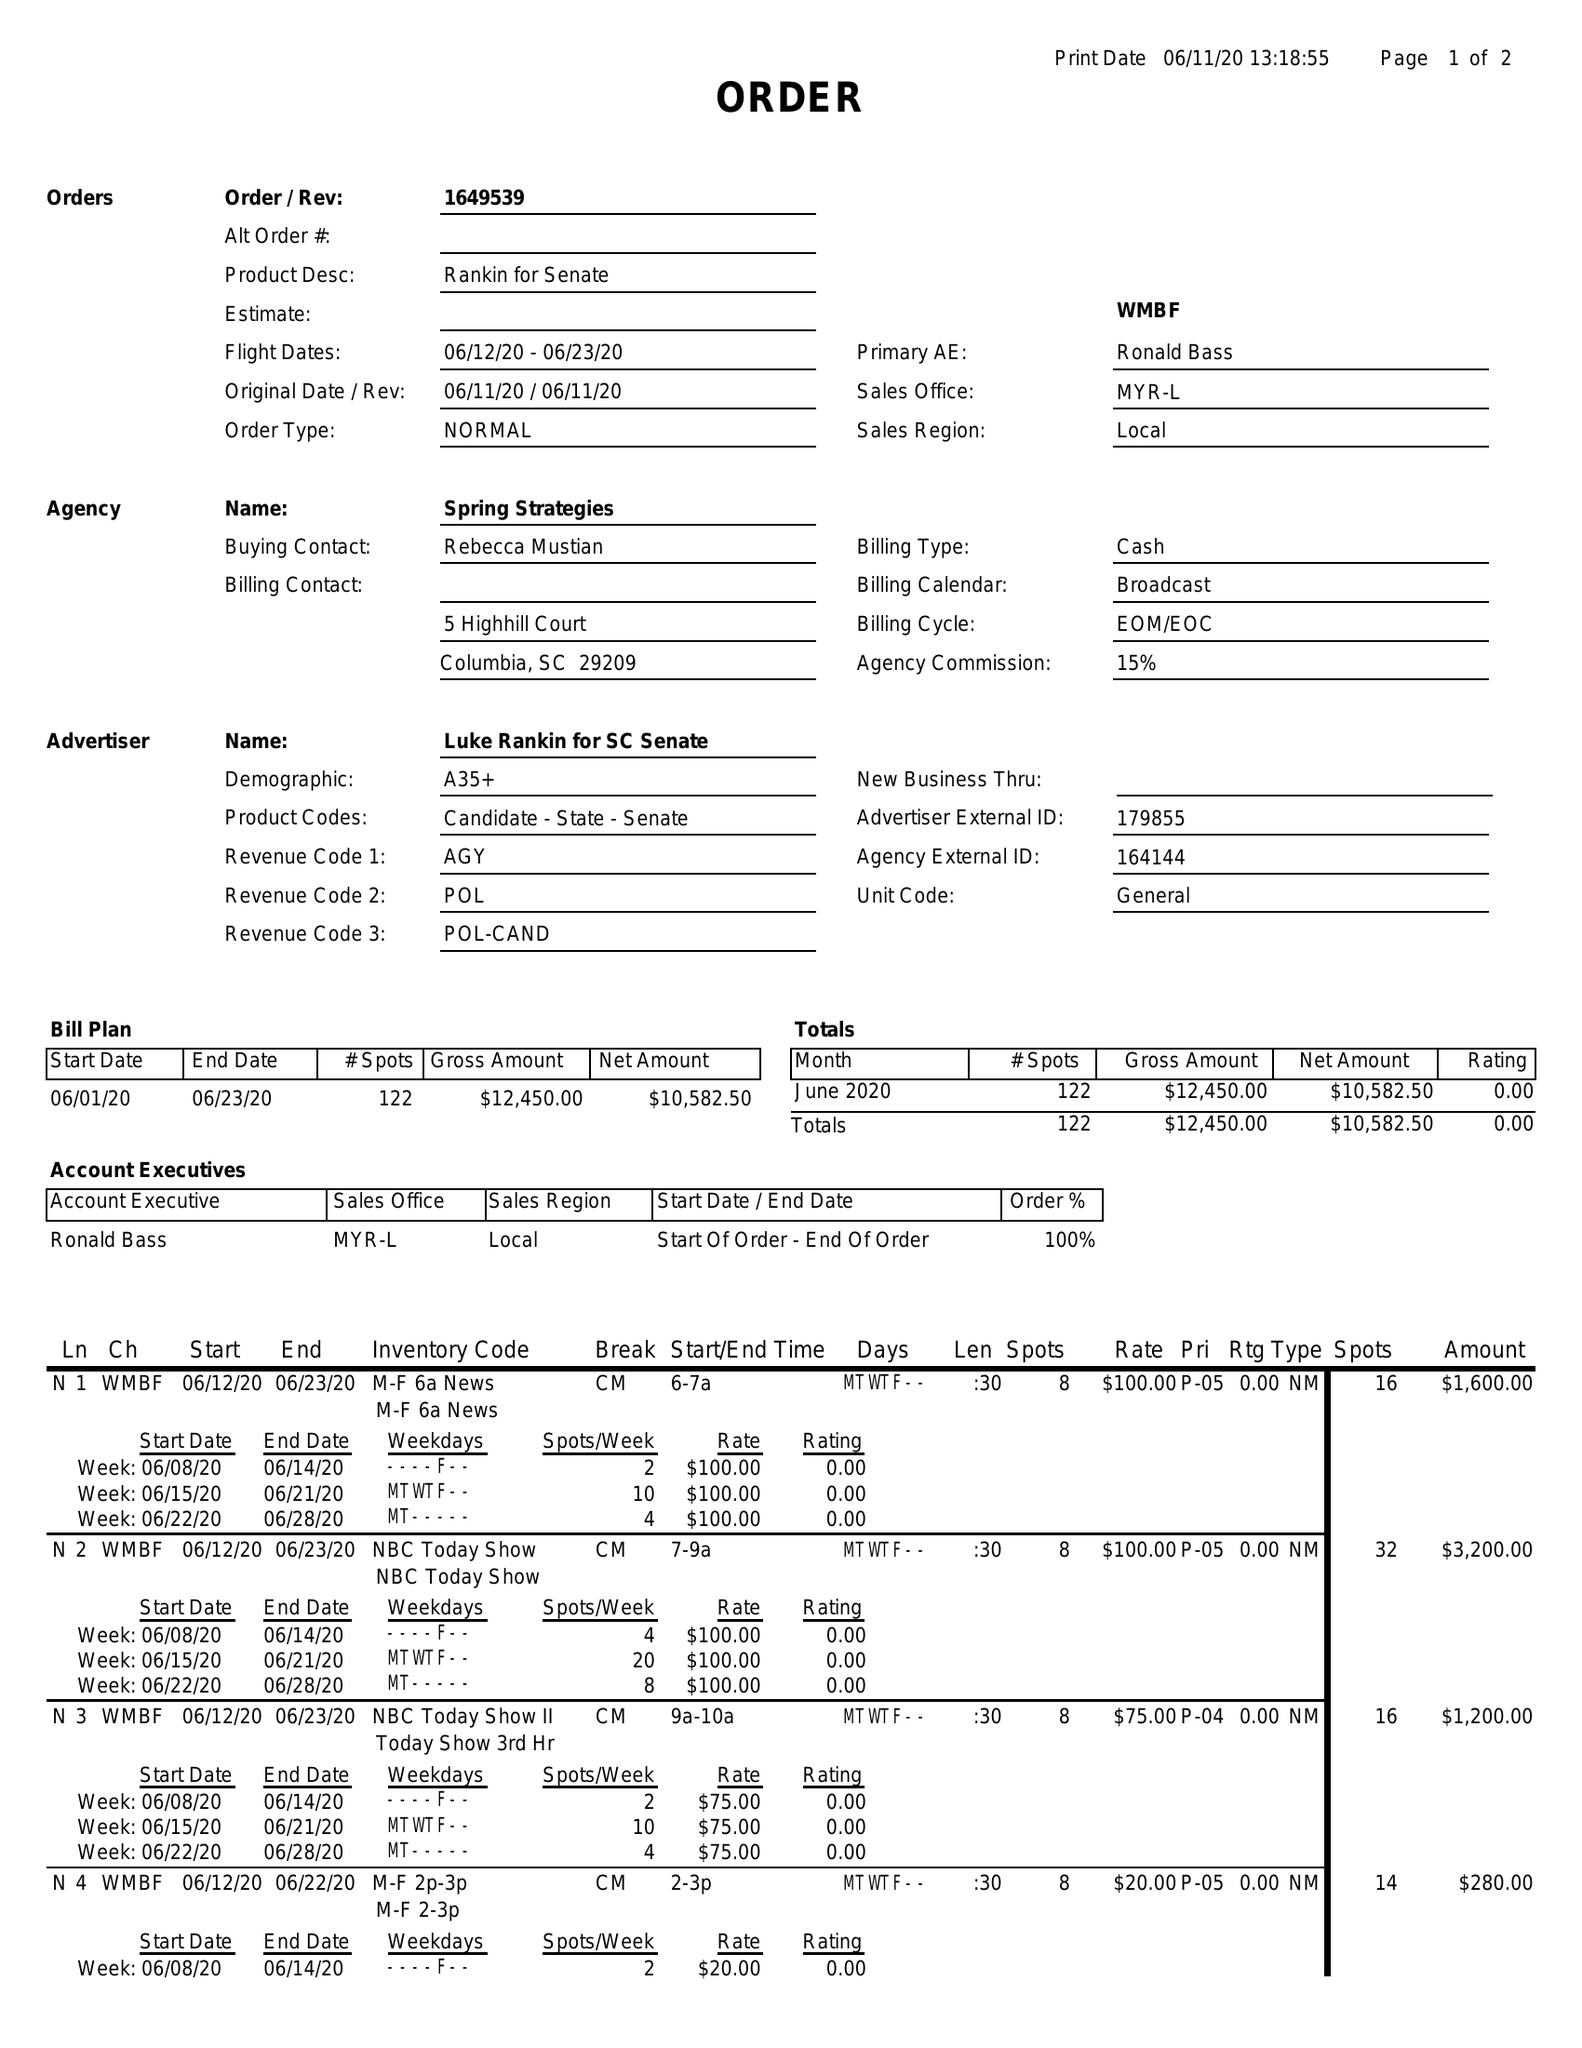What is the value for the flight_from?
Answer the question using a single word or phrase. 06/12/20 